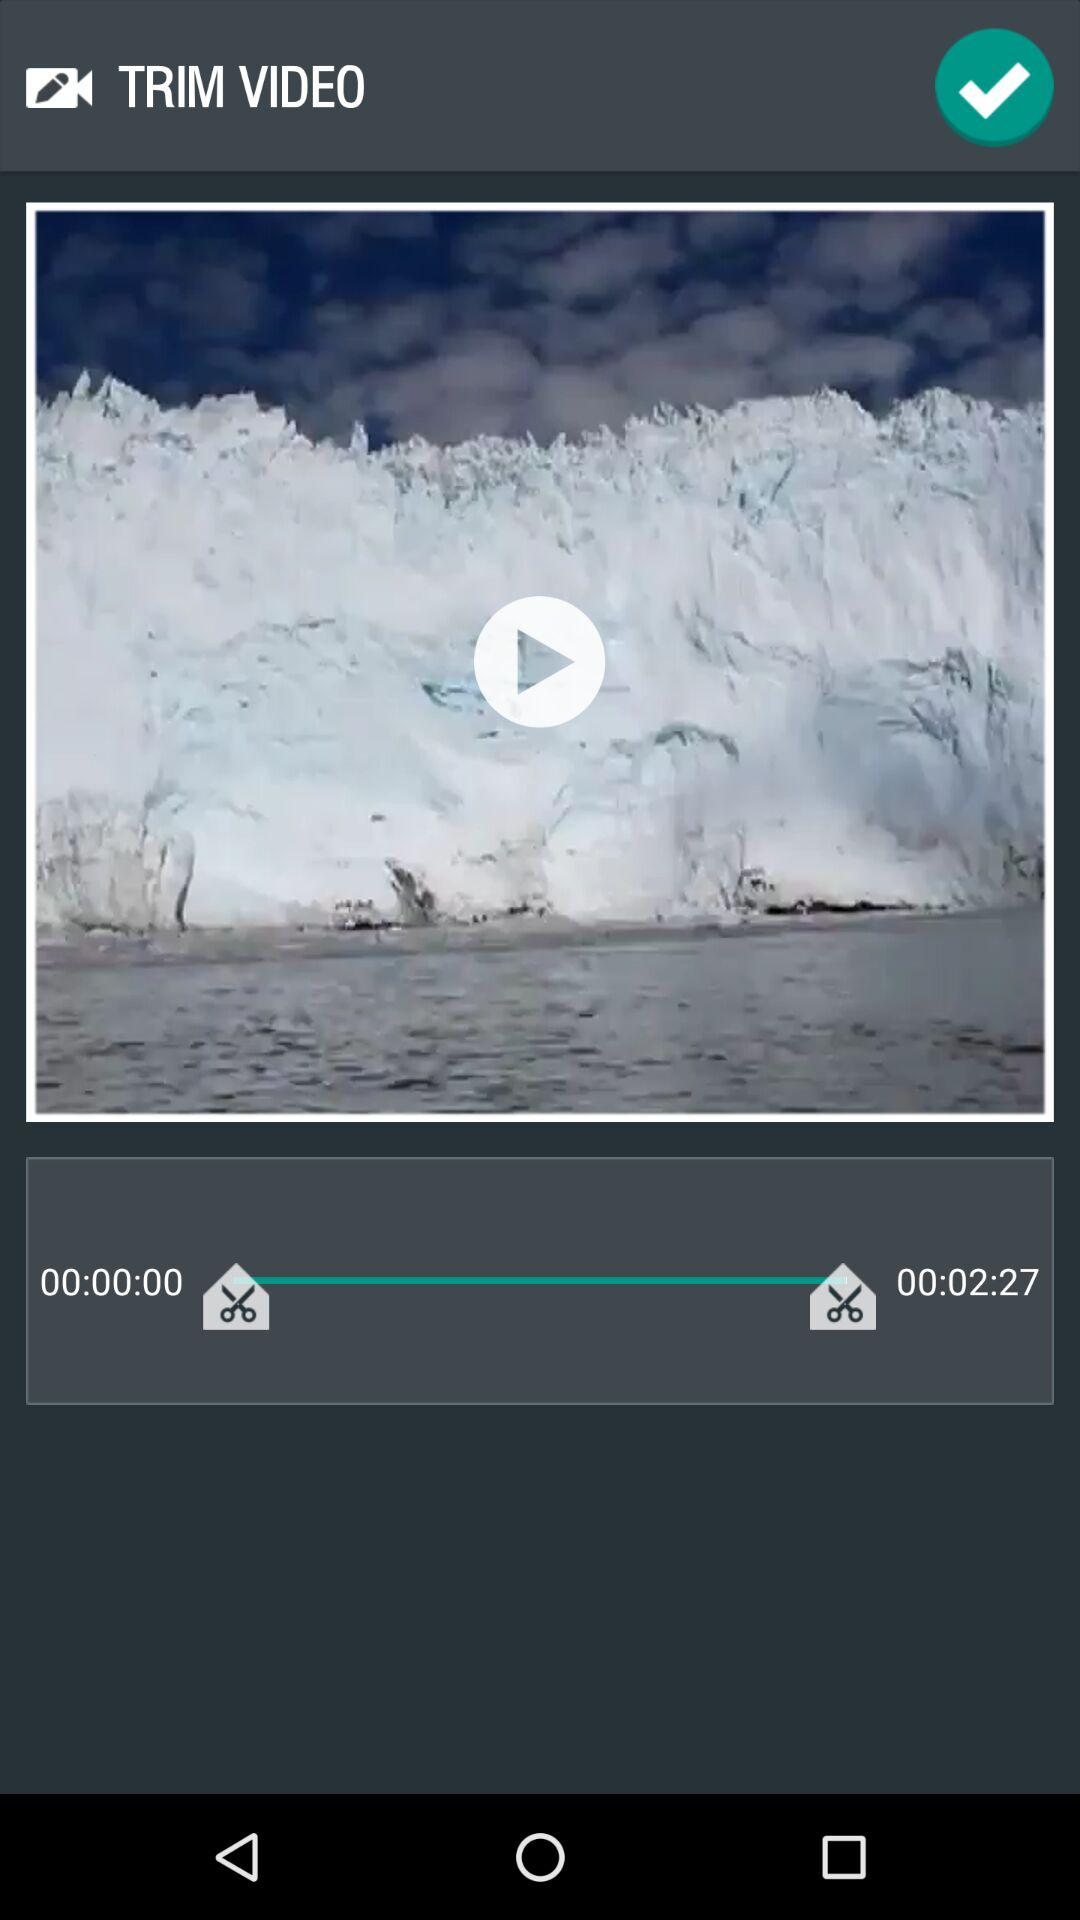How many scissors are there in the screenshot?
Answer the question using a single word or phrase. 2 